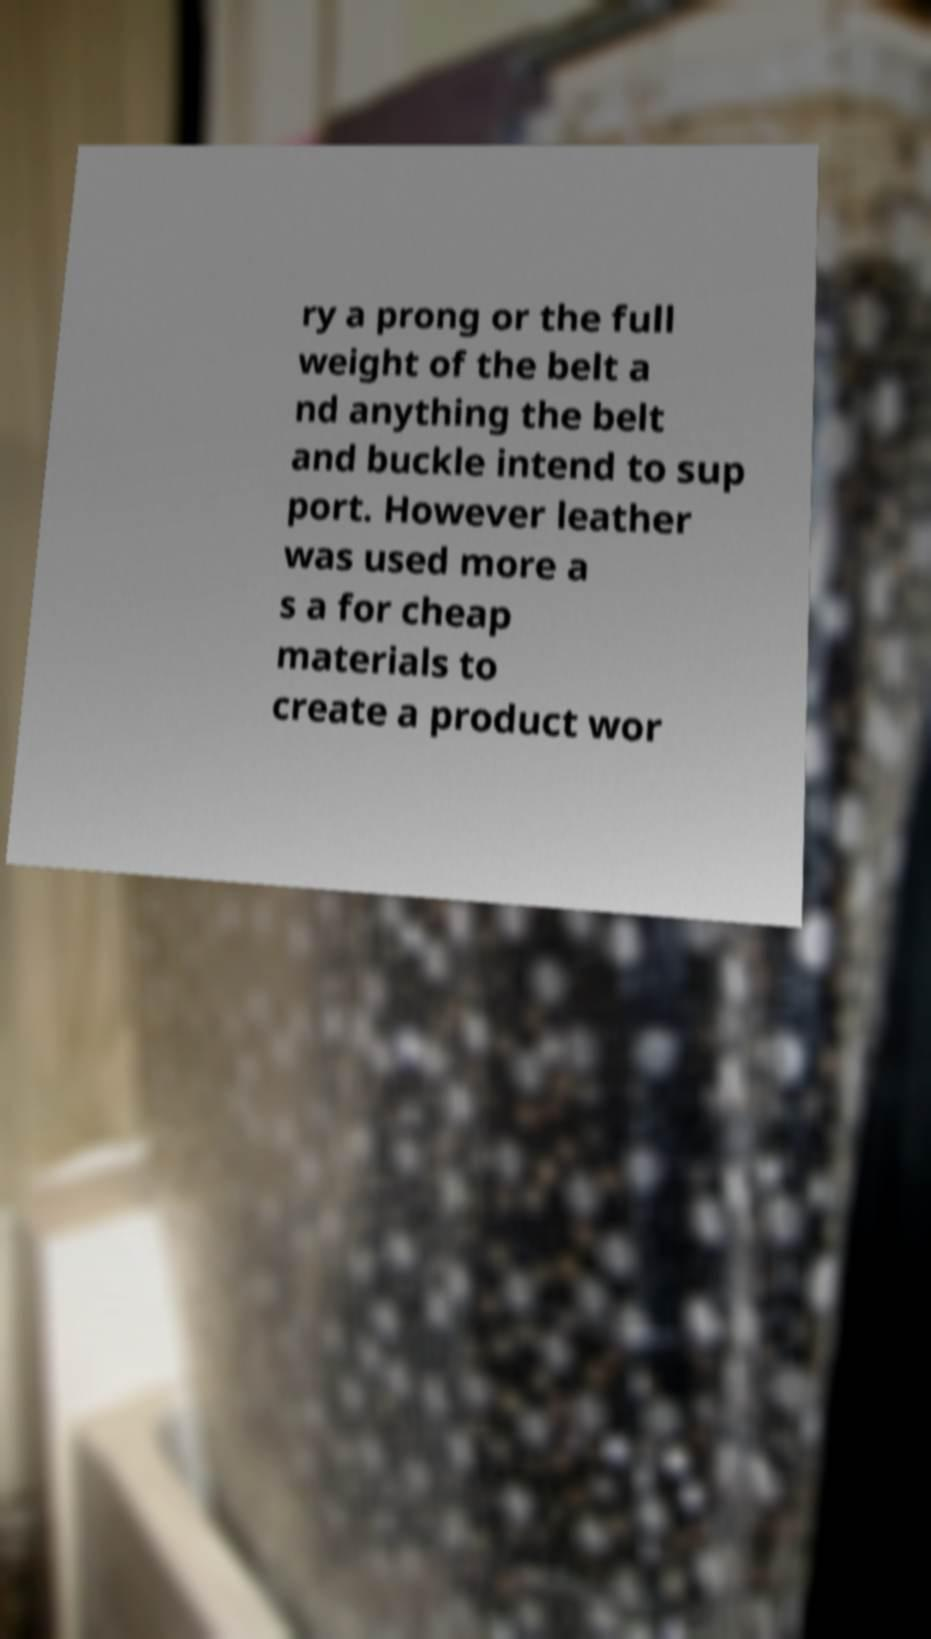Please identify and transcribe the text found in this image. ry a prong or the full weight of the belt a nd anything the belt and buckle intend to sup port. However leather was used more a s a for cheap materials to create a product wor 